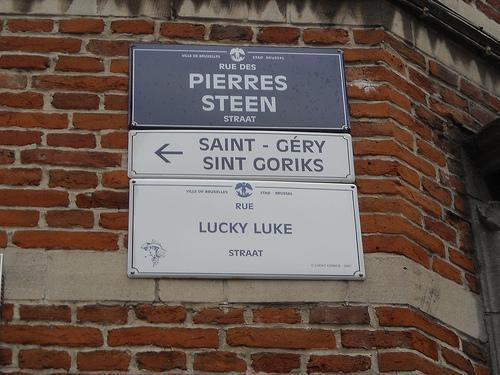How many people are pictured?
Give a very brief answer. 0. 